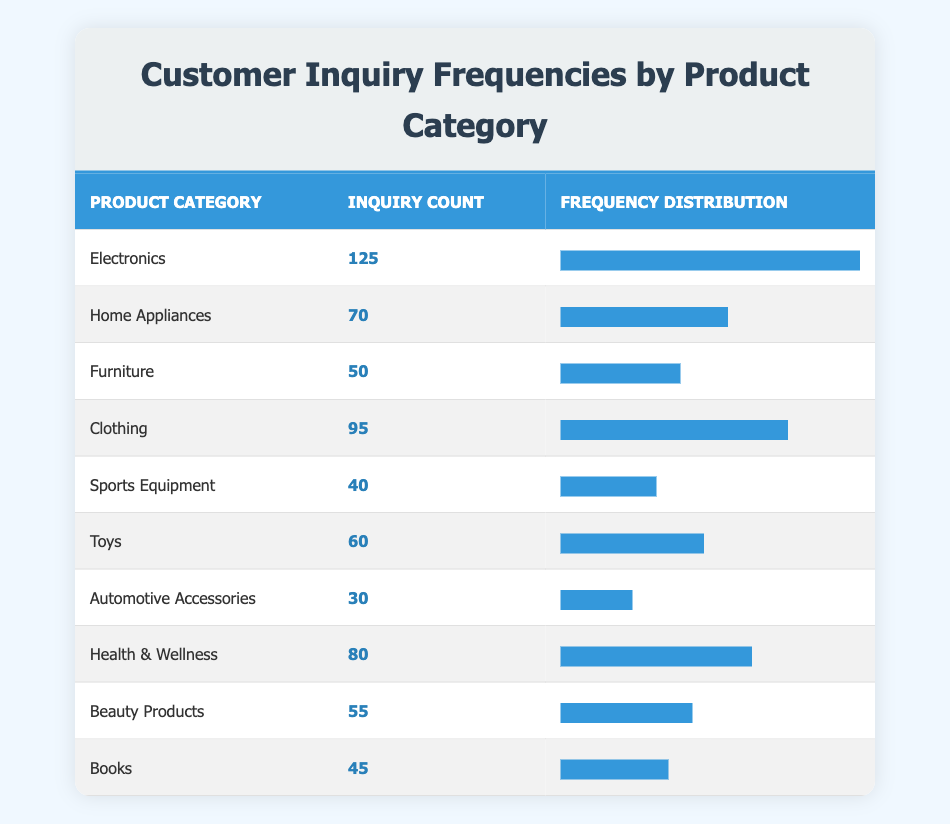What is the highest inquiry count among the product categories? The highest inquiry count is 125, which corresponds to the Electronics category. This can be observed in the Inquiry Count column of the table.
Answer: 125 How many product categories had inquiry counts above 70? The product categories with inquiry counts above 70 are Electronics (125), Clothing (95), Health & Wellness (80), and Home Appliances (70). This totals to four categories.
Answer: 4 What is the total inquiry count for the Furniture, Toys, and Beauty Products categories combined? The inquiry counts for these categories are: Furniture (50), Toys (60), and Beauty Products (55). Adding these values gives: 50 + 60 + 55 = 165.
Answer: 165 Is the inquiry count for Home Appliances greater than that for Health & Wellness? The inquiry count for Home Appliances is 70 and for Health & Wellness is 80. Since 70 is less than 80, the answer is no.
Answer: No What percentage of total inquiries does the Sports Equipment category represent? The total inquiry count from all categories is 125 + 70 + 50 + 95 + 40 + 60 + 30 + 80 + 55 + 45 = 750. The Sports Equipment category has an inquiry count of 40. To find the percentage, (40 / 750) * 100 = 5.33%.
Answer: 5.33% 